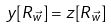<formula> <loc_0><loc_0><loc_500><loc_500>y [ R _ { \vec { w } } ] = z [ R _ { \vec { w } } ]</formula> 